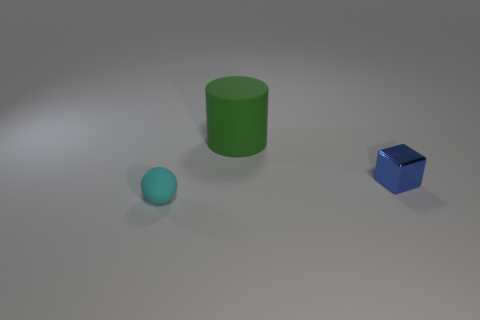Add 3 small cyan rubber spheres. How many objects exist? 6 Subtract all spheres. How many objects are left? 2 Add 2 yellow metal things. How many yellow metal things exist? 2 Subtract 0 brown blocks. How many objects are left? 3 Subtract all brown things. Subtract all cylinders. How many objects are left? 2 Add 3 blocks. How many blocks are left? 4 